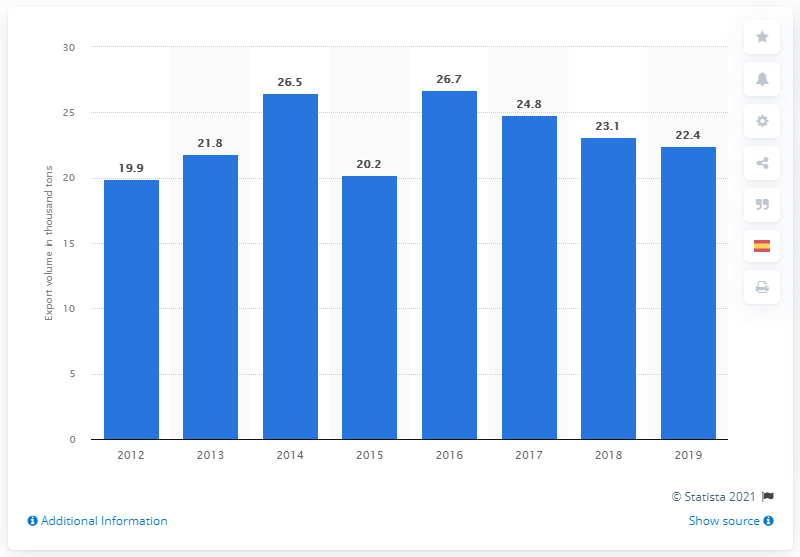Draw attention to some important aspects in this diagram. In 2016, the volume of honey exported from Spain reached its peak. 